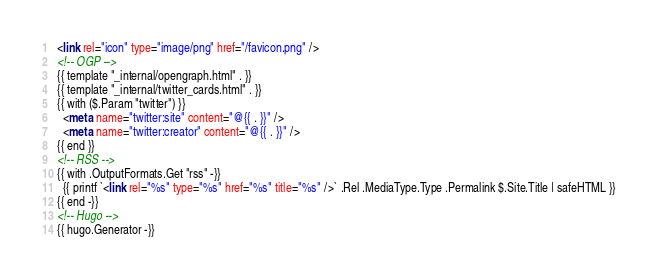<code> <loc_0><loc_0><loc_500><loc_500><_HTML_>  <link rel="icon" type="image/png" href="/favicon.png" />
  <!-- OGP -->
  {{ template "_internal/opengraph.html" . }}
  {{ template "_internal/twitter_cards.html" . }}
  {{ with ($.Param "twitter") }}
    <meta name="twitter:site" content="@{{ . }}" />
    <meta name="twitter:creator" content="@{{ . }}" />
  {{ end }}
  <!-- RSS -->
  {{ with .OutputFormats.Get "rss" -}}
    {{ printf `<link rel="%s" type="%s" href="%s" title="%s" />` .Rel .MediaType.Type .Permalink $.Site.Title | safeHTML }}
  {{ end -}}
  <!-- Hugo -->
  {{ hugo.Generator -}}
</code> 